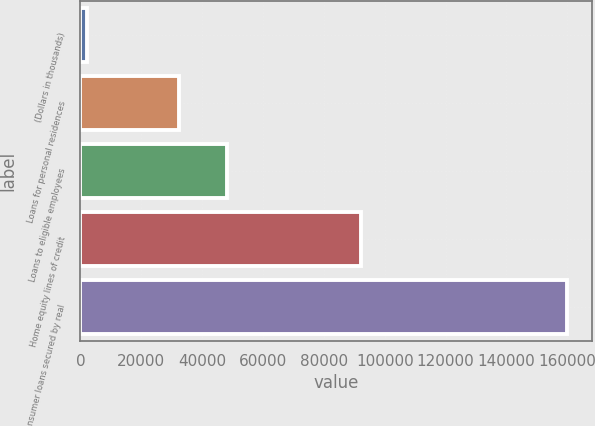<chart> <loc_0><loc_0><loc_500><loc_500><bar_chart><fcel>(Dollars in thousands)<fcel>Loans for personal residences<fcel>Loans to eligible employees<fcel>Home equity lines of credit<fcel>Consumer loans secured by real<nl><fcel>2006<fcel>32378<fcel>48179.3<fcel>92081<fcel>160019<nl></chart> 